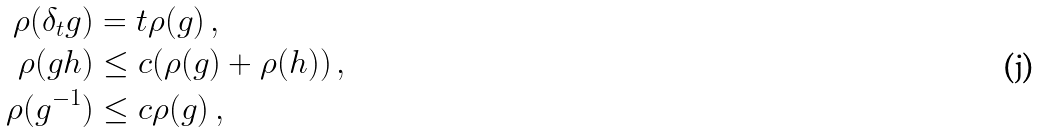Convert formula to latex. <formula><loc_0><loc_0><loc_500><loc_500>\rho ( \delta _ { t } g ) & = t \rho ( g ) \, , \\ \rho ( g h ) & \leq c ( \rho ( g ) + \rho ( h ) ) \, , \\ \rho ( g ^ { - 1 } ) & \leq c \rho ( g ) \, ,</formula> 